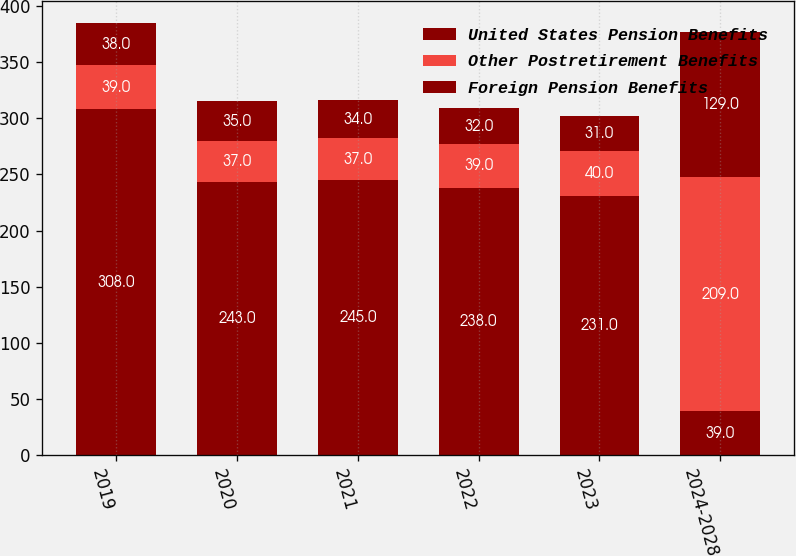<chart> <loc_0><loc_0><loc_500><loc_500><stacked_bar_chart><ecel><fcel>2019<fcel>2020<fcel>2021<fcel>2022<fcel>2023<fcel>2024-2028<nl><fcel>United States Pension Benefits<fcel>308<fcel>243<fcel>245<fcel>238<fcel>231<fcel>39<nl><fcel>Other Postretirement Benefits<fcel>39<fcel>37<fcel>37<fcel>39<fcel>40<fcel>209<nl><fcel>Foreign Pension Benefits<fcel>38<fcel>35<fcel>34<fcel>32<fcel>31<fcel>129<nl></chart> 